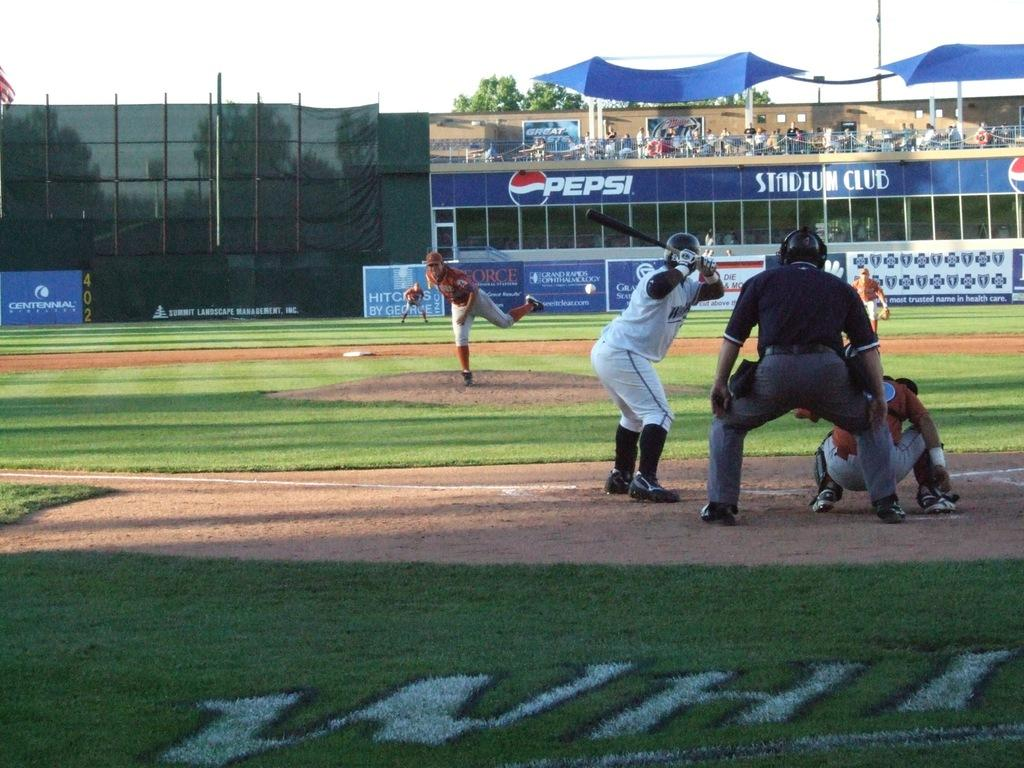Provide a one-sentence caption for the provided image. Pepsi and the logo are on a blue banner next to the stadium club. 